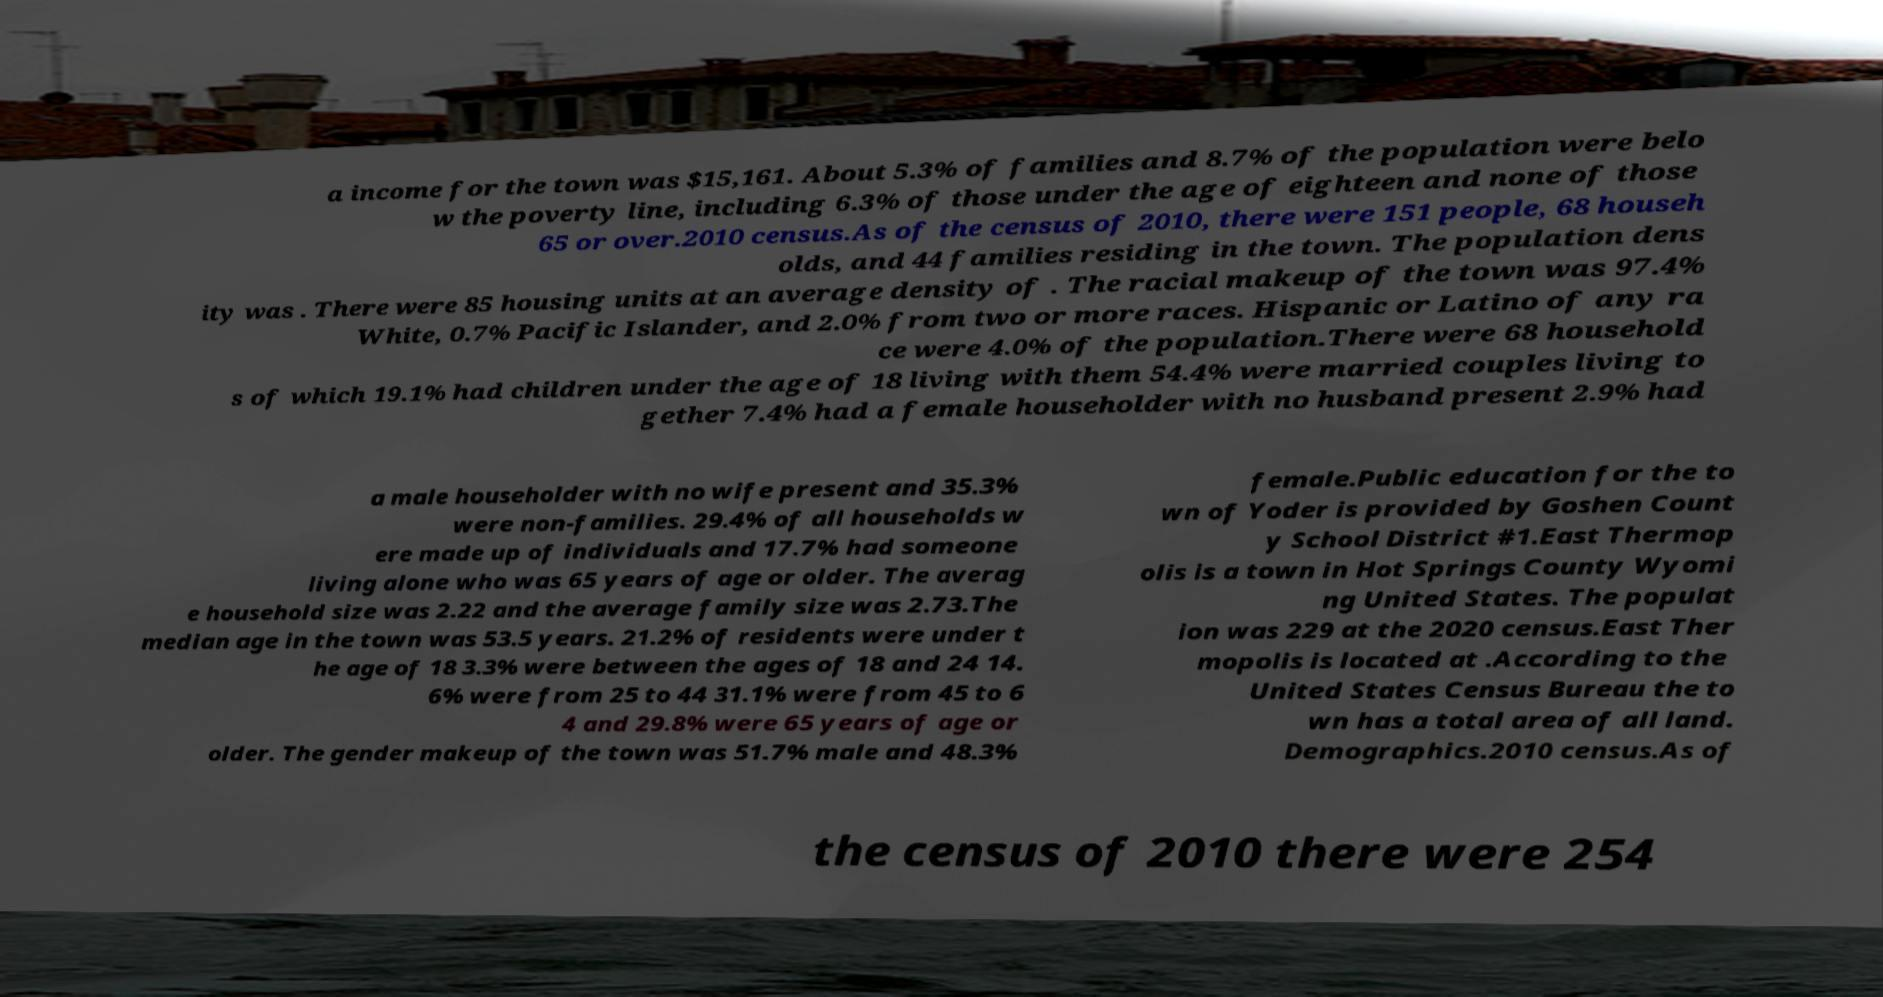What messages or text are displayed in this image? I need them in a readable, typed format. a income for the town was $15,161. About 5.3% of families and 8.7% of the population were belo w the poverty line, including 6.3% of those under the age of eighteen and none of those 65 or over.2010 census.As of the census of 2010, there were 151 people, 68 househ olds, and 44 families residing in the town. The population dens ity was . There were 85 housing units at an average density of . The racial makeup of the town was 97.4% White, 0.7% Pacific Islander, and 2.0% from two or more races. Hispanic or Latino of any ra ce were 4.0% of the population.There were 68 household s of which 19.1% had children under the age of 18 living with them 54.4% were married couples living to gether 7.4% had a female householder with no husband present 2.9% had a male householder with no wife present and 35.3% were non-families. 29.4% of all households w ere made up of individuals and 17.7% had someone living alone who was 65 years of age or older. The averag e household size was 2.22 and the average family size was 2.73.The median age in the town was 53.5 years. 21.2% of residents were under t he age of 18 3.3% were between the ages of 18 and 24 14. 6% were from 25 to 44 31.1% were from 45 to 6 4 and 29.8% were 65 years of age or older. The gender makeup of the town was 51.7% male and 48.3% female.Public education for the to wn of Yoder is provided by Goshen Count y School District #1.East Thermop olis is a town in Hot Springs County Wyomi ng United States. The populat ion was 229 at the 2020 census.East Ther mopolis is located at .According to the United States Census Bureau the to wn has a total area of all land. Demographics.2010 census.As of the census of 2010 there were 254 